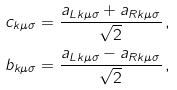<formula> <loc_0><loc_0><loc_500><loc_500>c _ { k \mu \sigma } & = \frac { a _ { L k \mu \sigma } + a _ { R k \mu \sigma } } { \sqrt { 2 } } \, , \\ b _ { k \mu \sigma } & = \frac { a _ { L k \mu \sigma } - a _ { R k \mu \sigma } } { \sqrt { 2 } } \, ,</formula> 